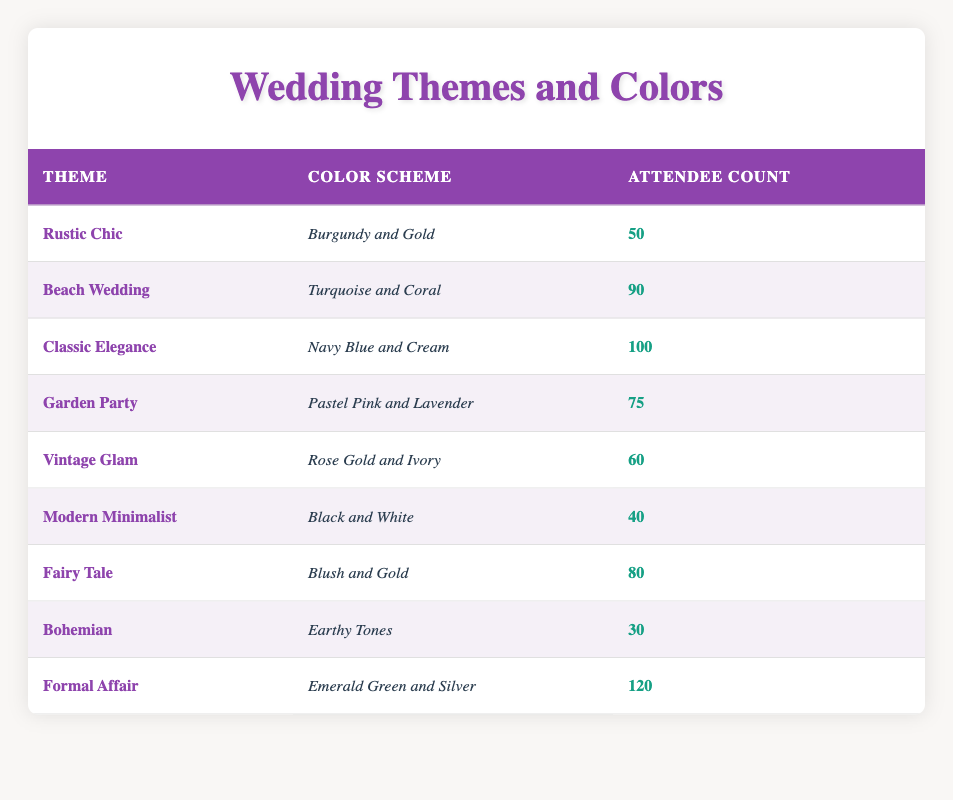What is the most popular theme based on the number of attendees? The theme with the highest number of attendees is "Formal Affair" with 120 attendees, the maximum count in the table.
Answer: Formal Affair How many attendees were planned for the "Garden Party" theme? The "Garden Party" theme has 75 attendees listed in the table under the attendee count column.
Answer: 75 Which color scheme is associated with the "Vintage Glam" theme? The "Vintage Glam" theme is associated with the color scheme "Rose Gold and Ivory," as directly indicated in the color scheme column next to the theme.
Answer: Rose Gold and Ivory What is the average number of attendees across all themes? To calculate the average, first I sum the attendee counts: 50 + 90 + 100 + 75 + 60 + 40 + 80 + 30 + 120 = 705. Then, divide by the number of themes, which is 9. So, 705/9 ≈ 78.33, rounding off gives us 78 as a concise average value.
Answer: 78 Is the "Beach Wedding" theme more popular than the "Bohemian" theme in terms of attendees? The "Beach Wedding" theme has 90 attendees, while the "Bohemian" theme has 30 attendees. Since 90 is greater than 30, the "Beach Wedding" theme is indeed more popular.
Answer: Yes Which themes have a total attendee count of less than 60? Looking through the attendee counts, "Modern Minimalist" has 40 and "Bohemian" has 30, which are below 60. Therefore the themes that meet this criterion are "Modern Minimalist" and "Bohemian."
Answer: Modern Minimalist, Bohemian What is the difference in attendee count between "Classic Elegance" and "Formal Affair"? The "Classic Elegance" theme has 100 attendees and the "Formal Affair" theme has 120. The difference is calculated by subtracting 100 from 120, which equals 20.
Answer: 20 How many themes have an attendee count greater than 75? By inspecting the table, the themes with more than 75 attendees are "Beach Wedding" (90), "Classic Elegance" (100), "Garden Party" (75), "Fairy Tale" (80), and "Formal Affair" (120). Counting these themes gives us five themes total.
Answer: 5 Is there a theme with exactly 30 attendees? Yes, the "Bohemian" theme has precisely 30 attendees as indicated in the table.
Answer: Yes 